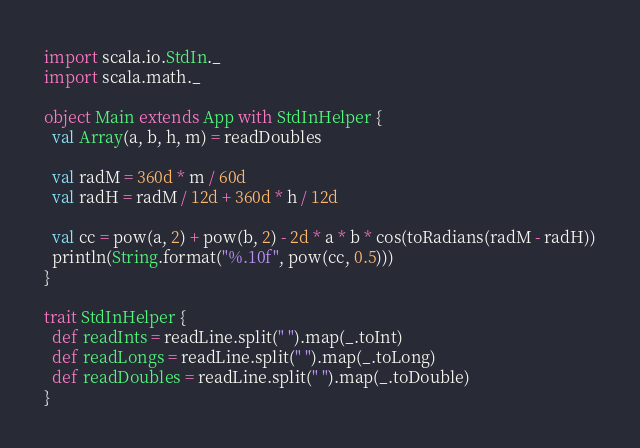Convert code to text. <code><loc_0><loc_0><loc_500><loc_500><_Scala_>import scala.io.StdIn._
import scala.math._

object Main extends App with StdInHelper {
  val Array(a, b, h, m) = readDoubles

  val radM = 360d * m / 60d
  val radH = radM / 12d + 360d * h / 12d

  val cc = pow(a, 2) + pow(b, 2) - 2d * a * b * cos(toRadians(radM - radH))
  println(String.format("%.10f", pow(cc, 0.5)))
}

trait StdInHelper {
  def readInts = readLine.split(" ").map(_.toInt)
  def readLongs = readLine.split(" ").map(_.toLong)
  def readDoubles = readLine.split(" ").map(_.toDouble)
}
</code> 